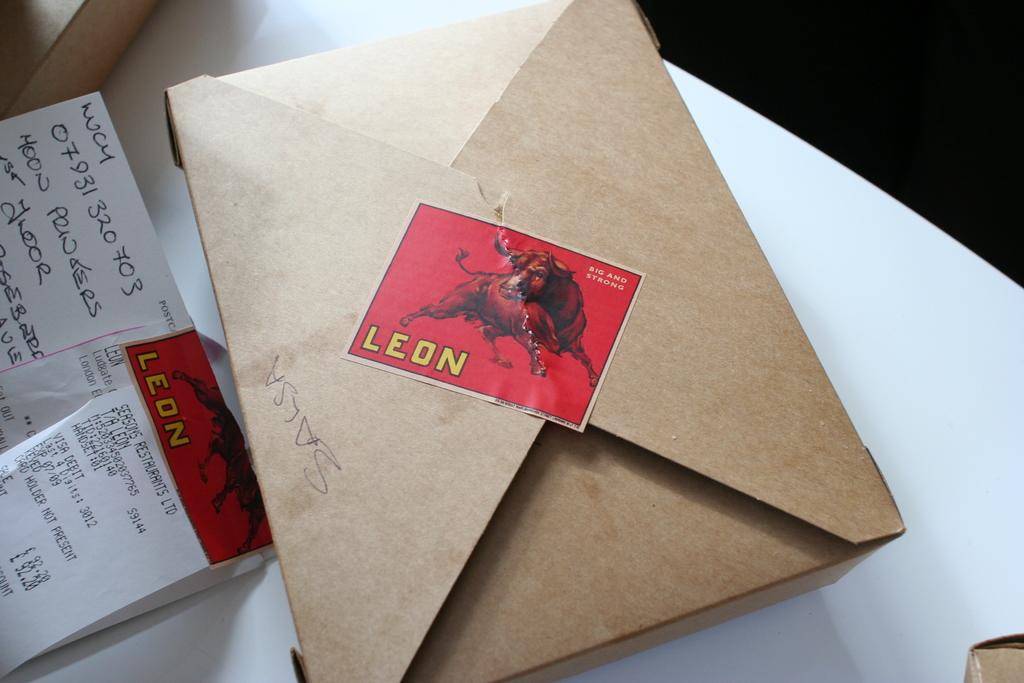What is in yellow on this stamp?
Your response must be concise. Leon. What number is written at the top of the white card?
Your answer should be compact. 07931320703. 